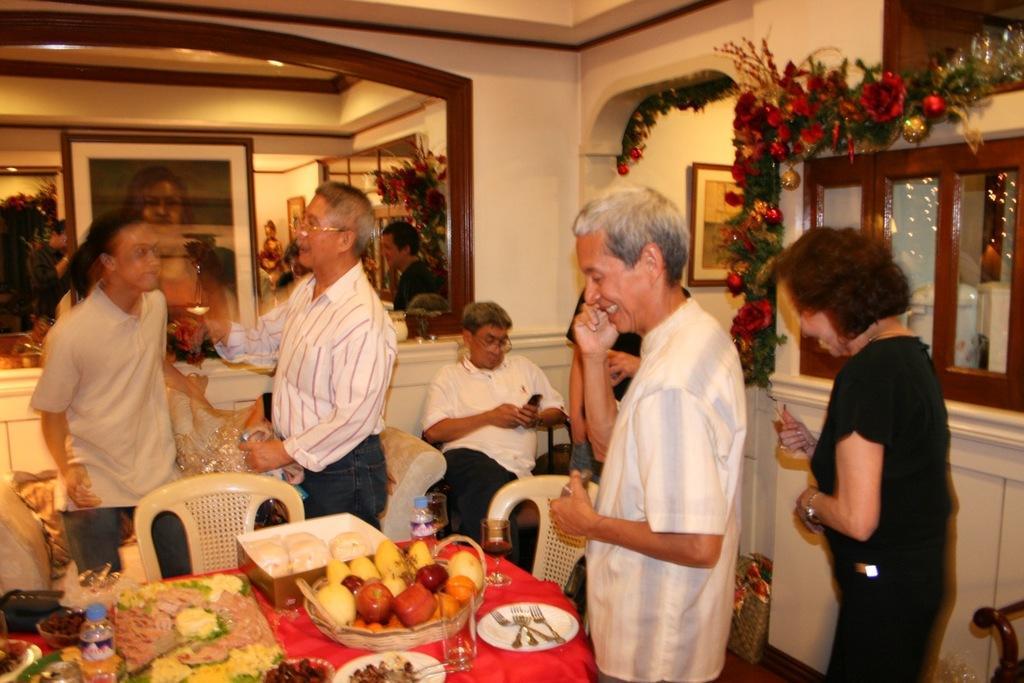In one or two sentences, can you explain what this image depicts? In this picture there is a man who is smiling. Backside of him we can see a woman who is wearing black dress. On the table we can see a basket, apples, mangoes, oranges, fork, plate, grapes, dates, fruits, water bottle, cotton box, red cloth, plastic cover, bowl and other objects. Here we can see a man who is sitting on the chair and looking on the phone. On the left we can see two persons standing near to the couch. On the top right we can see decoration with flowers on the wall. On the right there is a window. Here we can see a painting near to the decorations. On the top left there is a mirror. 